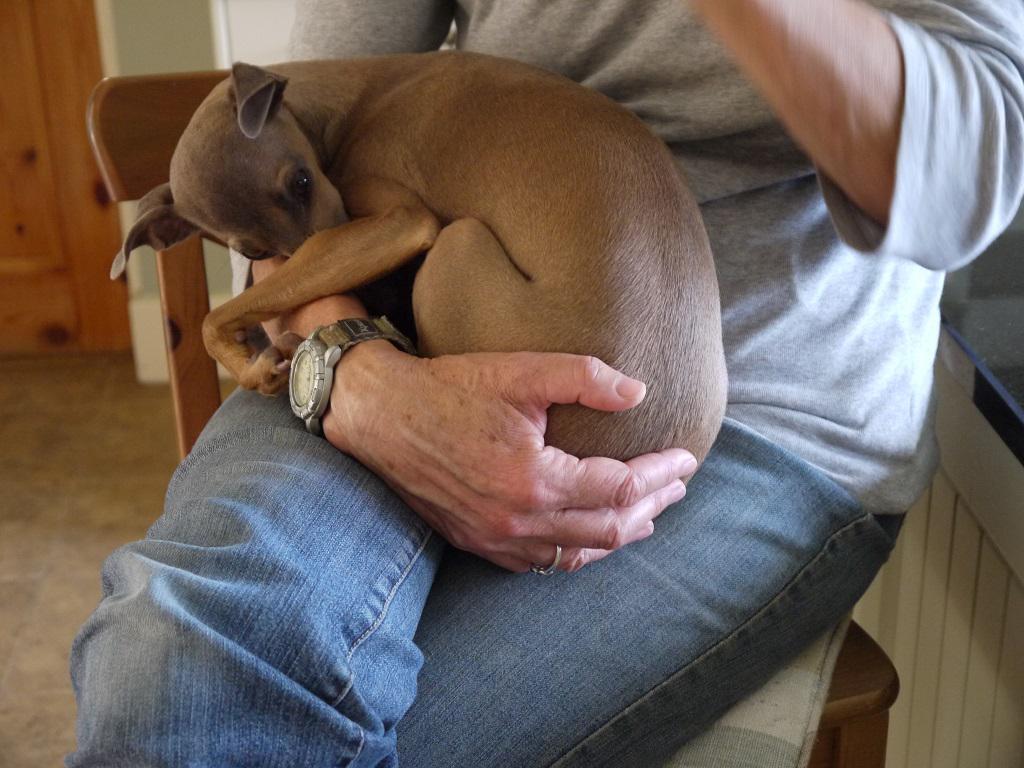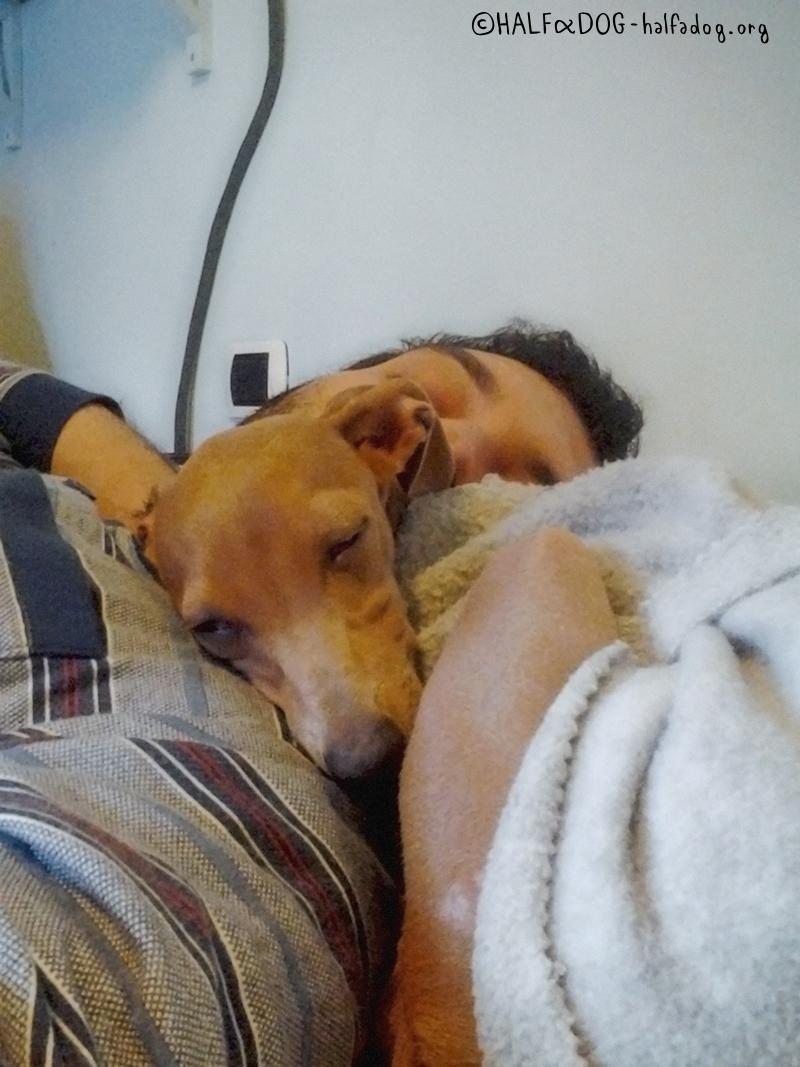The first image is the image on the left, the second image is the image on the right. Evaluate the accuracy of this statement regarding the images: "There are two dogs and zero humans, and the dog on the right is laying on a blanket.". Is it true? Answer yes or no. No. The first image is the image on the left, the second image is the image on the right. Assess this claim about the two images: "An image contains one leftward-facing snoozing brown dog, snuggled with folds of blanket and no human present.". Correct or not? Answer yes or no. No. 